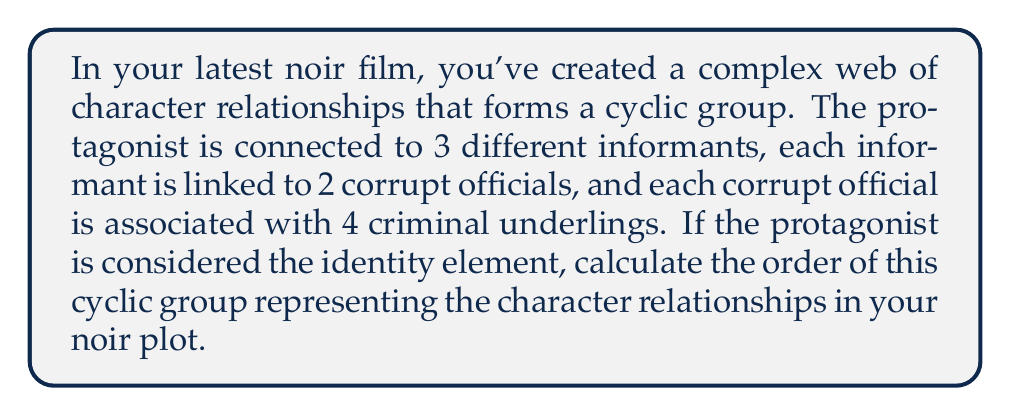Can you answer this question? Let's approach this step-by-step:

1) In a cyclic group, the order is determined by the number of unique elements generated by applying the group operation repeatedly to a generator.

2) In this case, we can consider the "connection" between characters as the group operation.

3) Starting from the protagonist (identity element), we have:
   - 1 protagonist
   - 3 informants
   - 6 corrupt officials (3 * 2)
   - 24 criminal underlings (6 * 4)

4) The total number of elements in the group is the sum of all these characters:

   $$1 + 3 + 6 + 24 = 34$$

5) However, this doesn't necessarily mean the order of the cyclic group is 34. We need to check if all these elements are unique when generated cyclically.

6) In a noir plot, it's common for characters to have multiple roles or connections. The cyclic nature suggests that after reaching the criminal underlings, we loop back to the protagonist.

7) Therefore, the order of the cyclic group is indeed 34, as each application of the "connection" operation generates a unique element until we complete the cycle and return to the protagonist.

This cyclic structure mirrors the circular nature of many noir plots, where the protagonist often ends up back where they started, but changed by the journey through the underworld of crime and corruption.
Answer: The order of the cyclic group representing character relationships in the noir plot is 34. 